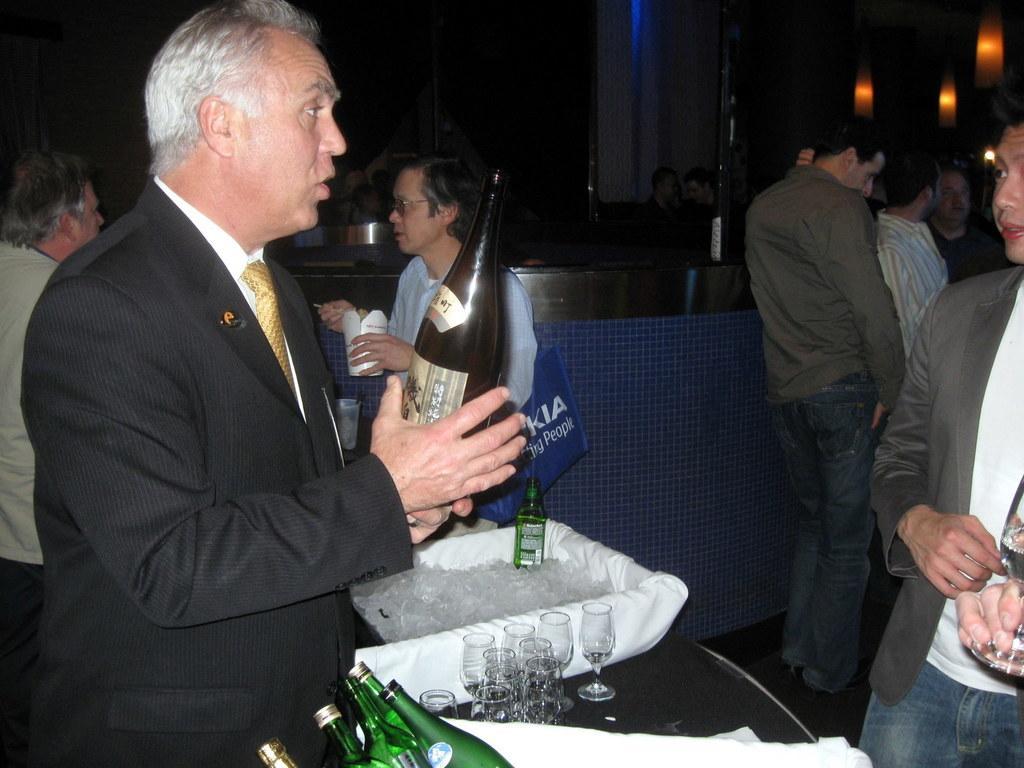Describe this image in one or two sentences. In this image I can see a person wearing white shirt, gold tie and black blazer is standing and holding a bottle in his hand. In front of him I can see few other wine bottles, few wine glasses, a tray with ice and bottle in it. I can see few other persons standing. In the background I can see few lamps and few other persons. 